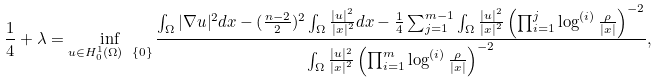<formula> <loc_0><loc_0><loc_500><loc_500>\frac { 1 } { 4 } + \lambda = \inf _ { u \in H _ { 0 } ^ { 1 } ( \Omega ) \ \{ 0 \} } \frac { \int _ { \Omega } | \nabla u | ^ { 2 } d x - ( \frac { n - 2 } { 2 } ) ^ { 2 } \int _ { \Omega } \frac { | u | ^ { 2 } } { | x | ^ { 2 } } d x - \frac { 1 } { 4 } \sum ^ { m - 1 } _ { j = 1 } \int _ { \Omega } \frac { | u | ^ { 2 } } { | x | ^ { 2 } } \left ( \prod ^ { j } _ { i = 1 } \log ^ { ( i ) } \frac { \rho } { | x | } \right ) ^ { - 2 } } { \int _ { \Omega } \frac { | u | ^ { 2 } } { | x | ^ { 2 } } \left ( \prod ^ { m } _ { i = 1 } \log ^ { ( i ) } \frac { \rho } { | x | } \right ) ^ { - 2 } } ,</formula> 